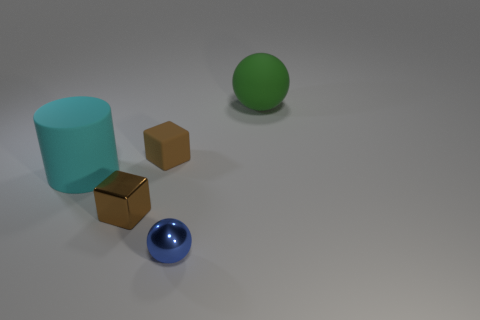Add 3 large spheres. How many objects exist? 8 Subtract all blocks. How many objects are left? 3 Add 5 small brown rubber blocks. How many small brown rubber blocks exist? 6 Subtract 0 red cubes. How many objects are left? 5 Subtract all brown metal cubes. Subtract all large green things. How many objects are left? 3 Add 4 brown things. How many brown things are left? 6 